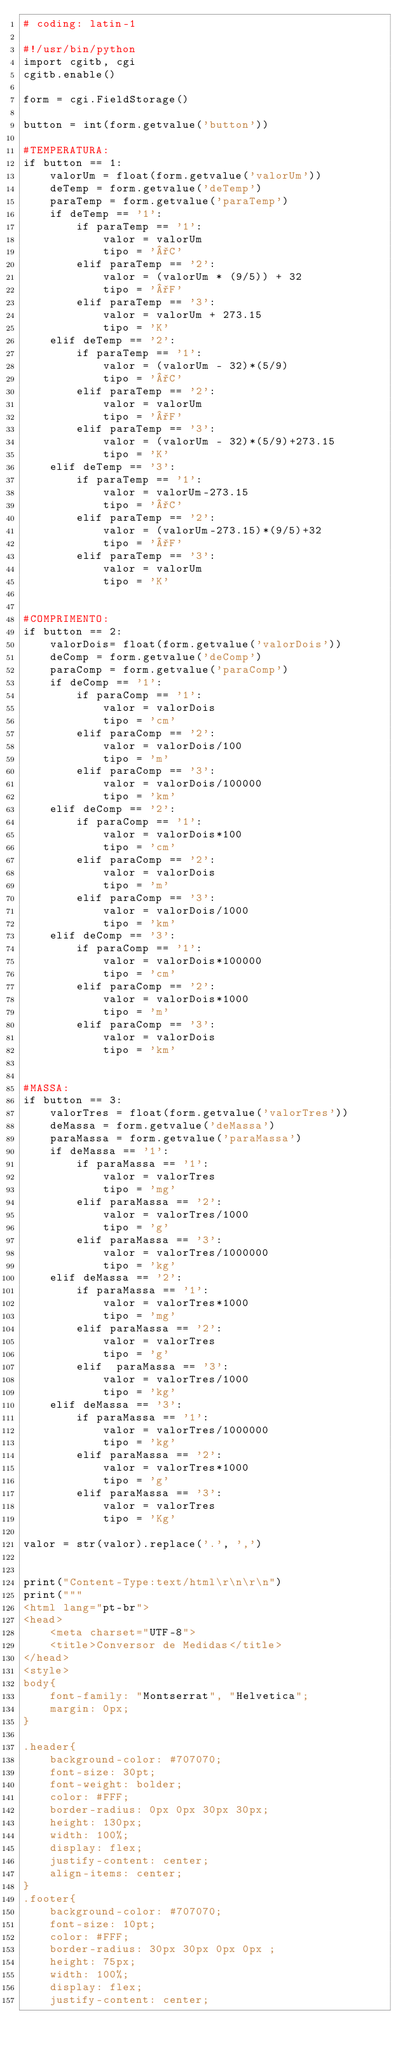<code> <loc_0><loc_0><loc_500><loc_500><_Python_># coding: latin-1

#!/usr/bin/python
import cgitb, cgi
cgitb.enable()

form = cgi.FieldStorage()

button = int(form.getvalue('button'))

#TEMPERATURA:
if button == 1:
    valorUm = float(form.getvalue('valorUm'))
    deTemp = form.getvalue('deTemp')
    paraTemp = form.getvalue('paraTemp')
    if deTemp == '1':
        if paraTemp == '1':
            valor = valorUm
            tipo = '°C'
        elif paraTemp == '2':
            valor = (valorUm * (9/5)) + 32
            tipo = '°F'
        elif paraTemp == '3':
            valor = valorUm + 273.15
            tipo = 'K'
    elif deTemp == '2':
        if paraTemp == '1':
            valor = (valorUm - 32)*(5/9)
            tipo = '°C'
        elif paraTemp == '2':
            valor = valorUm
            tipo = '°F'
        elif paraTemp == '3':
            valor = (valorUm - 32)*(5/9)+273.15
            tipo = 'K'
    elif deTemp == '3':
        if paraTemp == '1':
            valor = valorUm-273.15
            tipo = '°C'
        elif paraTemp == '2':
            valor = (valorUm-273.15)*(9/5)+32
            tipo = '°F'
        elif paraTemp == '3':
            valor = valorUm
            tipo = 'K'


#COMPRIMENTO:
if button == 2:
    valorDois= float(form.getvalue('valorDois'))
    deComp = form.getvalue('deComp')
    paraComp = form.getvalue('paraComp')
    if deComp == '1':
        if paraComp == '1':
            valor = valorDois
            tipo = 'cm'
        elif paraComp == '2':
            valor = valorDois/100
            tipo = 'm'
        elif paraComp == '3':
            valor = valorDois/100000
            tipo = 'km'
    elif deComp == '2':
        if paraComp == '1':
            valor = valorDois*100
            tipo = 'cm'
        elif paraComp == '2':
            valor = valorDois
            tipo = 'm'
        elif paraComp == '3':
            valor = valorDois/1000
            tipo = 'km'
    elif deComp == '3':
        if paraComp == '1':
            valor = valorDois*100000
            tipo = 'cm'
        elif paraComp == '2':
            valor = valorDois*1000
            tipo = 'm'
        elif paraComp == '3':
            valor = valorDois
            tipo = 'km'


#MASSA:
if button == 3:
    valorTres = float(form.getvalue('valorTres'))
    deMassa = form.getvalue('deMassa')
    paraMassa = form.getvalue('paraMassa')
    if deMassa == '1':
        if paraMassa == '1':
            valor = valorTres
            tipo = 'mg'
        elif paraMassa == '2':
            valor = valorTres/1000
            tipo = 'g'
        elif paraMassa == '3':
            valor = valorTres/1000000
            tipo = 'kg'
    elif deMassa == '2':
        if paraMassa == '1':
            valor = valorTres*1000
            tipo = 'mg'
        elif paraMassa == '2':
            valor = valorTres
            tipo = 'g'
        elif  paraMassa == '3':
            valor = valorTres/1000
            tipo = 'kg'
    elif deMassa == '3':
        if paraMassa == '1':
            valor = valorTres/1000000
            tipo = 'kg'
        elif paraMassa == '2':
            valor = valorTres*1000
            tipo = 'g'
        elif paraMassa == '3':
            valor = valorTres
            tipo = 'Kg'

valor = str(valor).replace('.', ',')


print("Content-Type:text/html\r\n\r\n")
print("""
<html lang="pt-br">
<head>
    <meta charset="UTF-8">
    <title>Conversor de Medidas</title>
</head>
<style>
body{
    font-family: "Montserrat", "Helvetica";
    margin: 0px;
}

.header{
    background-color: #707070;
    font-size: 30pt;
    font-weight: bolder;
    color: #FFF;
    border-radius: 0px 0px 30px 30px;
    height: 130px;
    width: 100%;
    display: flex;
    justify-content: center;
    align-items: center;
}
.footer{
    background-color: #707070;
    font-size: 10pt;
    color: #FFF;
    border-radius: 30px 30px 0px 0px ;
    height: 75px;
    width: 100%;
    display: flex;
    justify-content: center;</code> 